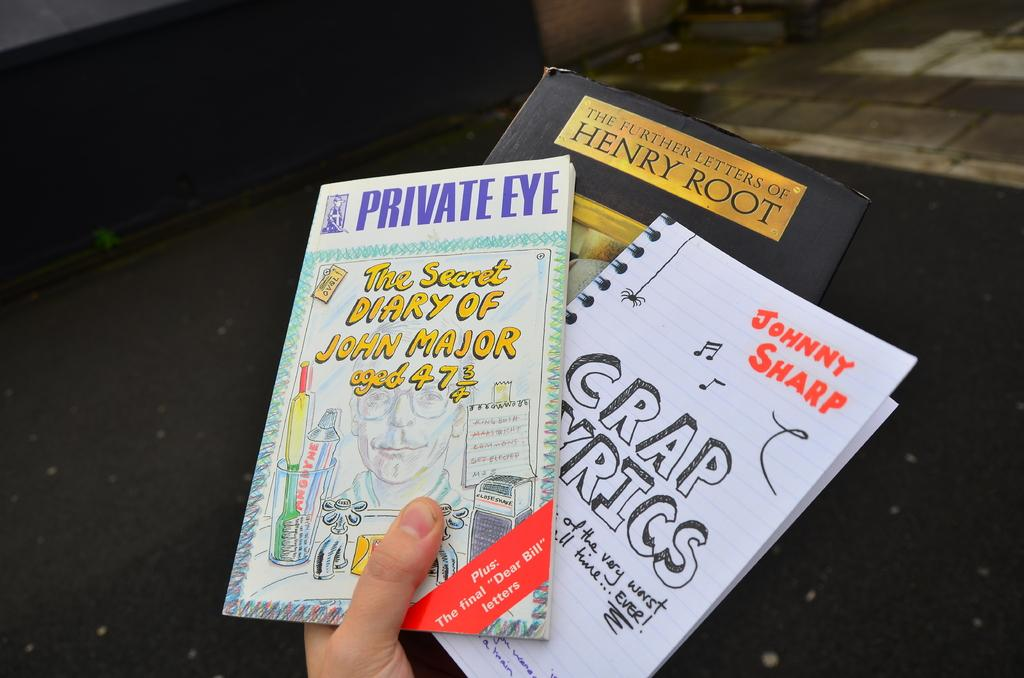What is the person in the image holding? The person is holding books in the image. Can you describe the books in more detail? There is writing on the cover page of the books. What can be seen in the background of the image? There is a black and ash color surface in the background of the image. What type of suit is the person wearing in the image? There is no suit visible in the image; the person is holding books. How much debt does the person owe in the image? There is no information about debt in the image; it only shows a person holding books with writing on the cover page. 